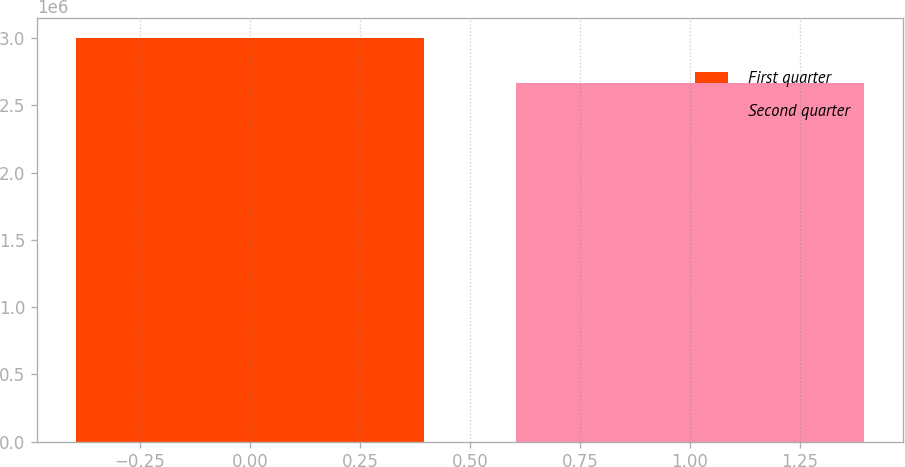<chart> <loc_0><loc_0><loc_500><loc_500><bar_chart><fcel>First quarter<fcel>Second quarter<nl><fcel>3e+06<fcel>2.6692e+06<nl></chart> 